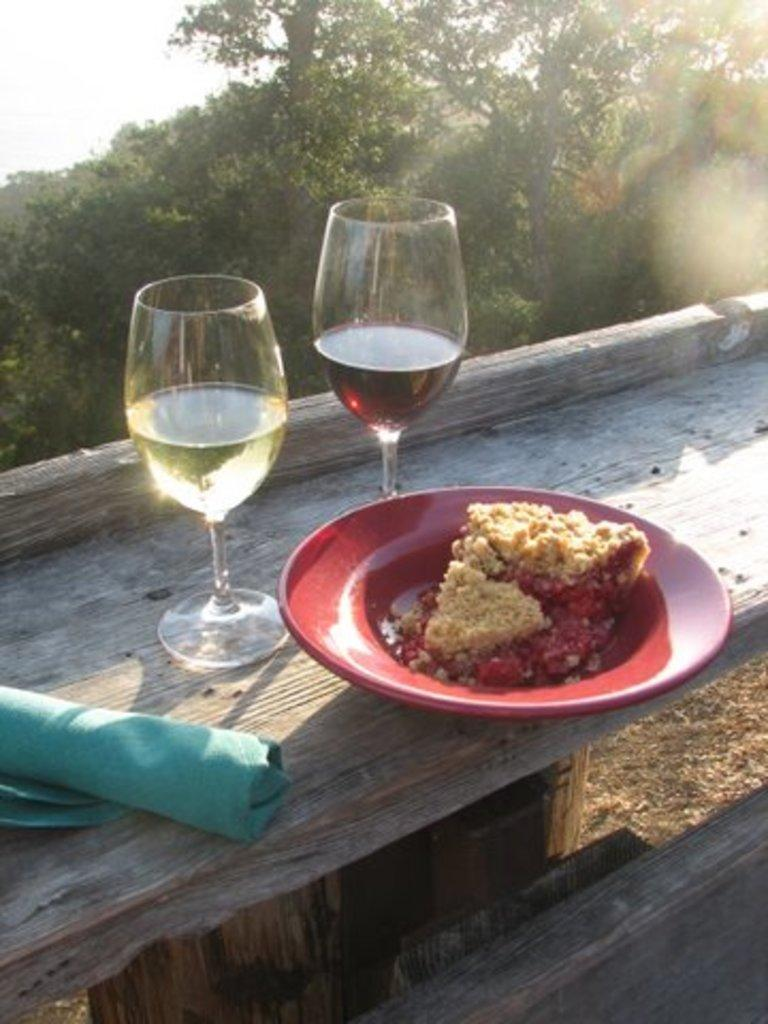What is on the plate that is visible in the image? There is a plate containing food in the image. What type of glasses are present in the image? There are wine glasses in the image. What might be used for cleaning or wiping in the image? A napkin is present in the image for cleaning or wiping. Where are the plate, wine glasses, and napkin placed in the image? The plate, wine glasses, and napkin are placed on a bench in the image. What can be seen in the background of the image? Trees and the sky are visible in the background of the image. What type of humor does the governor display in the image? There is no governor present in the image, and therefore no humor can be observed. 